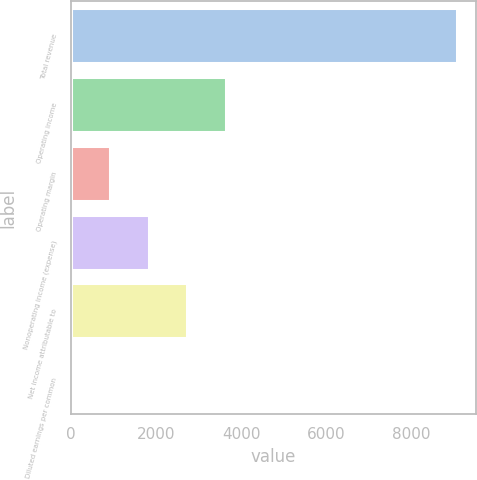Convert chart. <chart><loc_0><loc_0><loc_500><loc_500><bar_chart><fcel>Total revenue<fcel>Operating income<fcel>Operating margin<fcel>Nonoperating income (expense)<fcel>Net income attributable to<fcel>Diluted earnings per common<nl><fcel>9081<fcel>3639.81<fcel>919.23<fcel>1826.09<fcel>2732.95<fcel>12.37<nl></chart> 